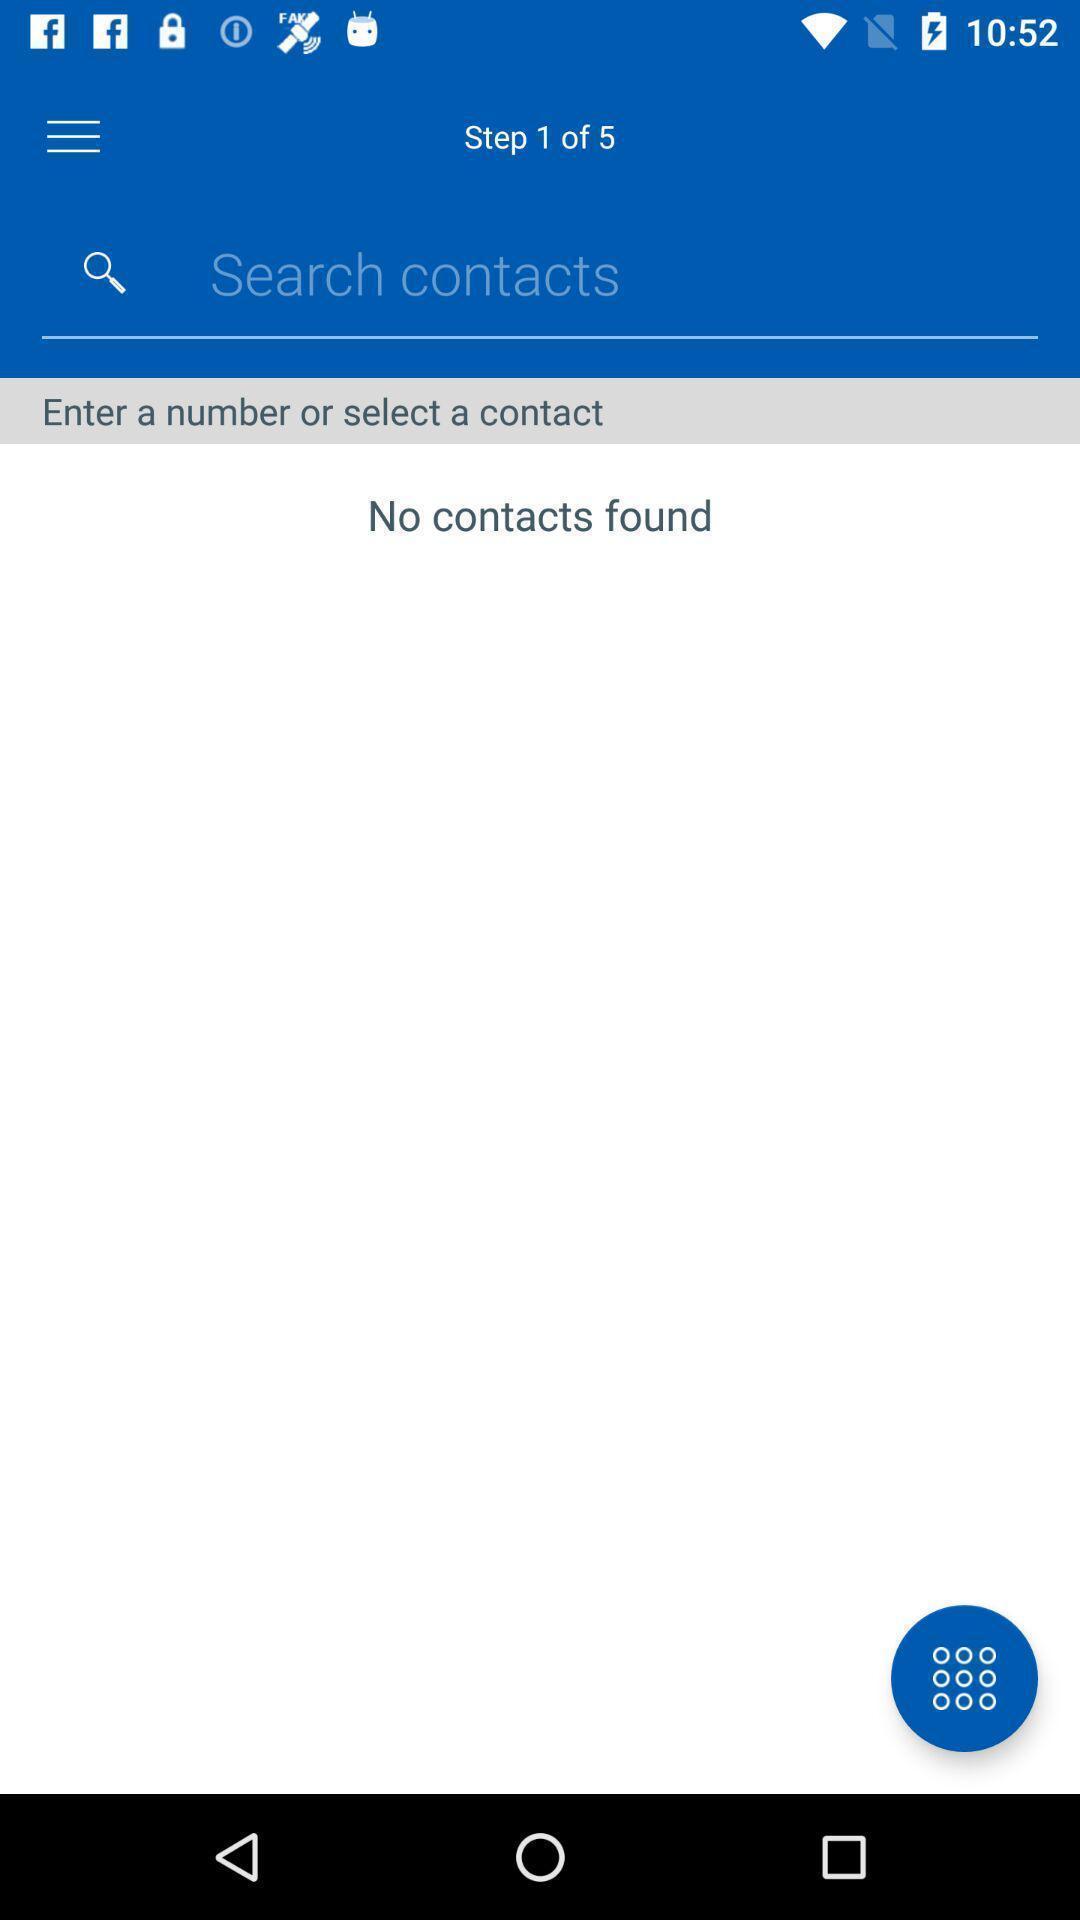Provide a textual representation of this image. Search page to find contacts. 